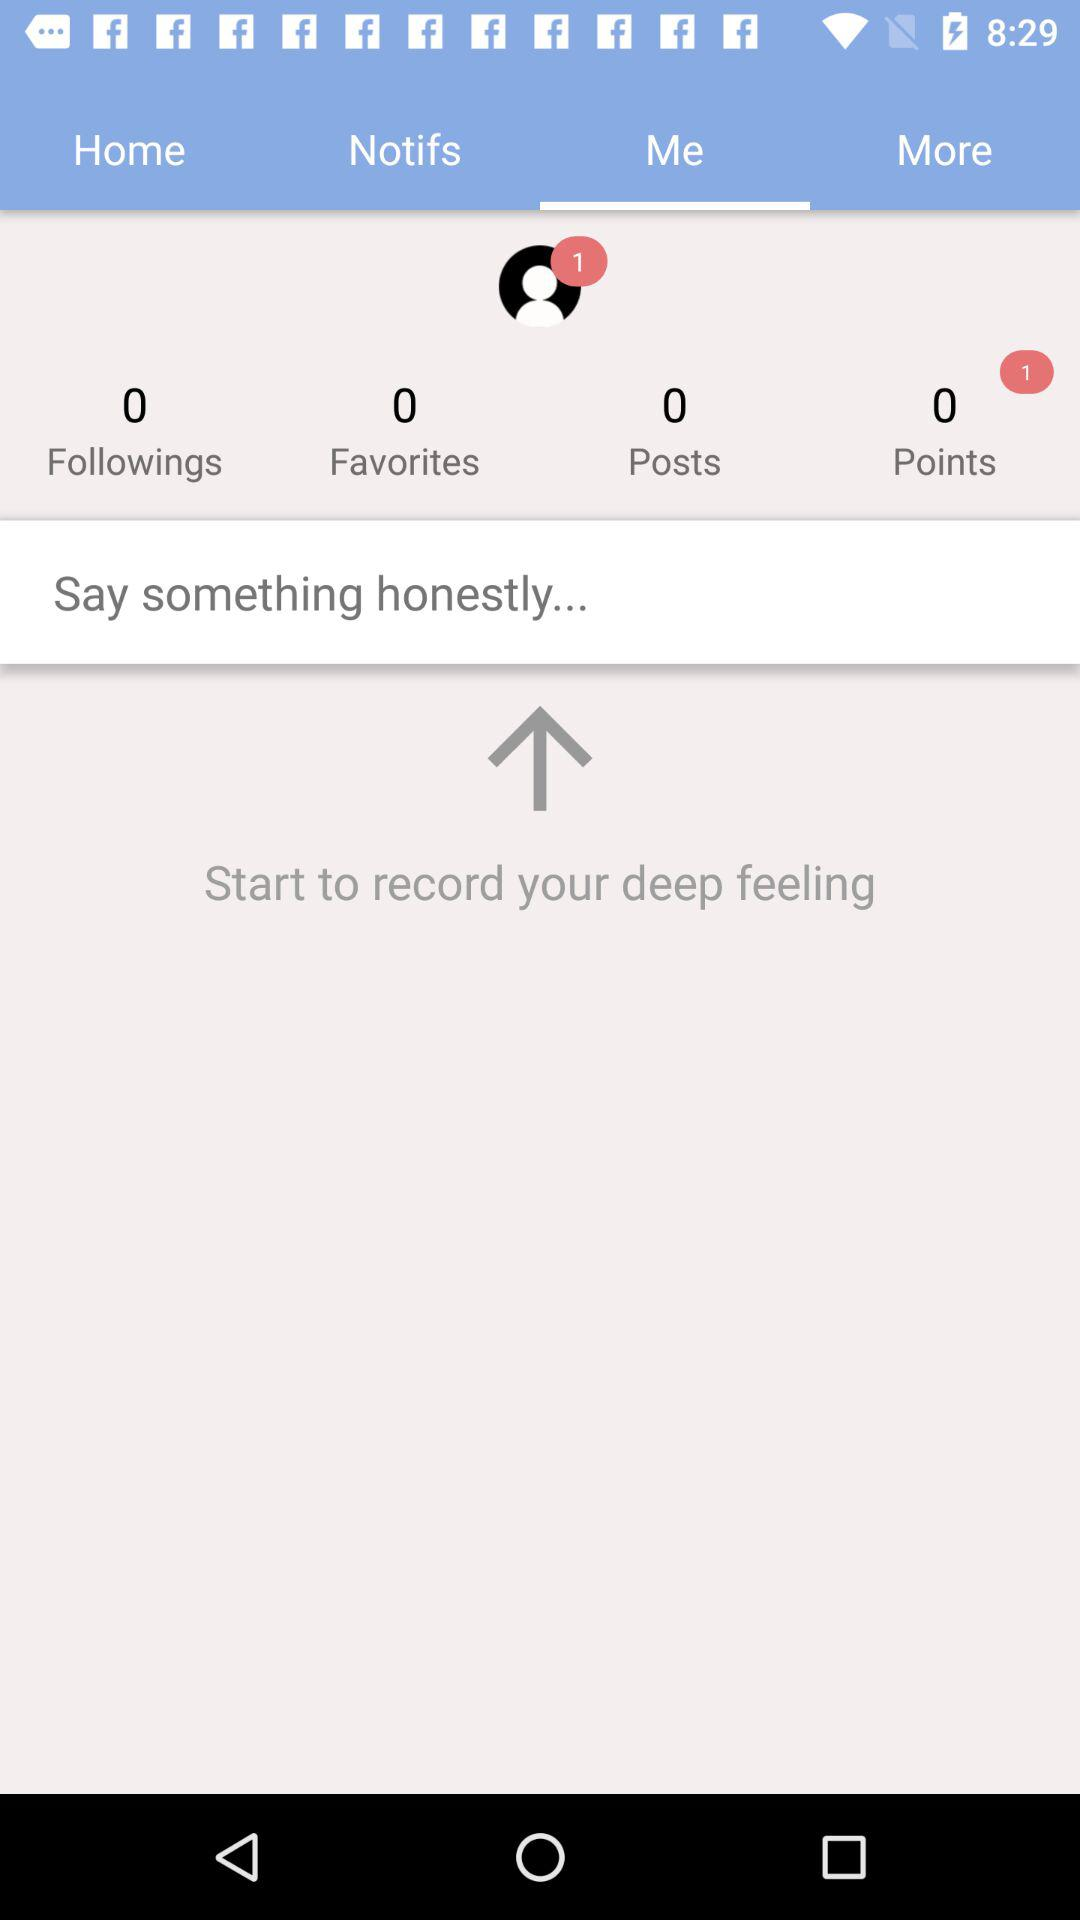What is the number of notifications? The number of notifications is 1. 